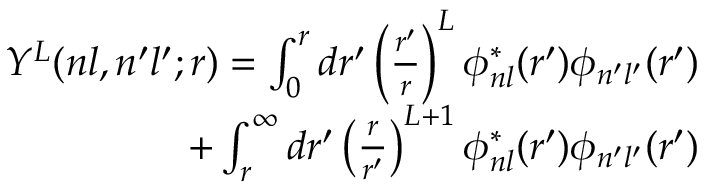Convert formula to latex. <formula><loc_0><loc_0><loc_500><loc_500>\begin{array} { r } { Y ^ { L } ( n l , n ^ { \prime } l ^ { \prime } ; r ) = \int _ { 0 } ^ { r } d r ^ { \prime } \left ( \frac { r ^ { \prime } } { r } \right ) ^ { L } \phi _ { n l } ^ { * } ( r ^ { \prime } ) \phi _ { n ^ { \prime } l ^ { \prime } } ( r ^ { \prime } ) } \\ { + \int _ { r } ^ { \infty } d r ^ { \prime } \left ( \frac { r } { r ^ { \prime } } \right ) ^ { L + 1 } \phi _ { n l } ^ { * } ( r ^ { \prime } ) \phi _ { n ^ { \prime } l ^ { \prime } } ( r ^ { \prime } ) } \end{array}</formula> 